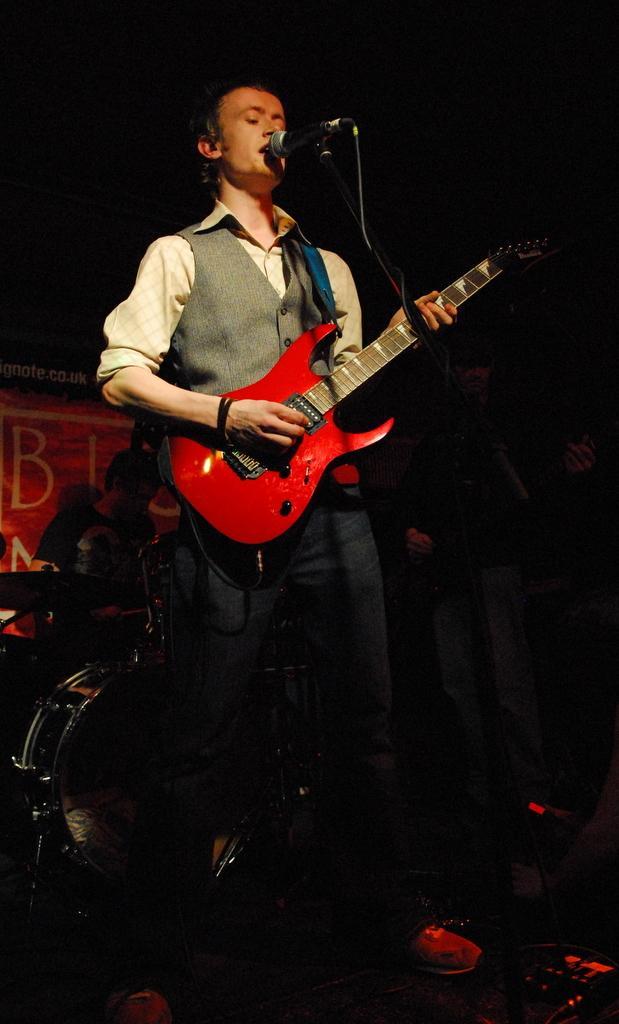Please provide a concise description of this image. In this image two persons are standing and holding guitar. Person at the front side is before a mike stand. Person at the left side is playing a musical instrument. 